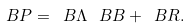Convert formula to latex. <formula><loc_0><loc_0><loc_500><loc_500>\ B { P } = \ B { \Lambda } \, \ B { B } + \ B { R } .</formula> 